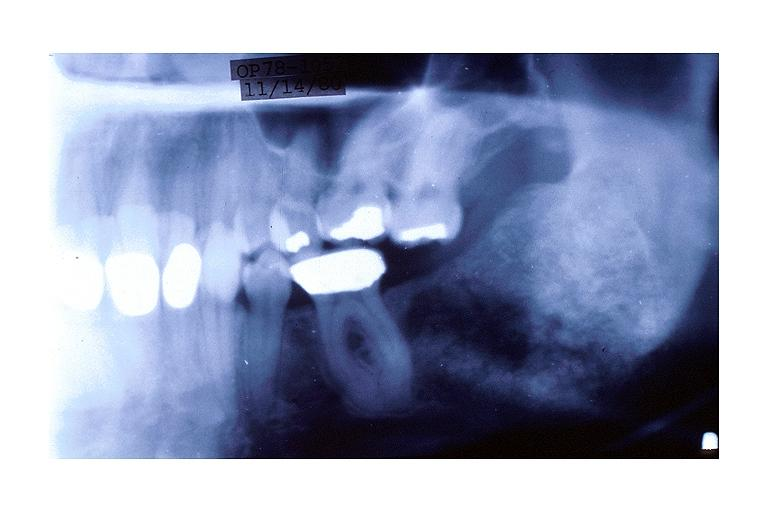s oral present?
Answer the question using a single word or phrase. Yes 